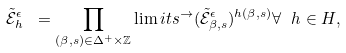Convert formula to latex. <formula><loc_0><loc_0><loc_500><loc_500>\tilde { \mathcal { E } } ^ { \epsilon } _ { h } \ = \prod _ { ( \beta , s ) \in \Delta ^ { + } \times \mathbb { Z } } \lim i t s ^ { \rightarrow } ( \tilde { \mathcal { E } } ^ { \epsilon } _ { \beta , s } ) ^ { h ( \beta , s ) } \forall \ h \in H ,</formula> 